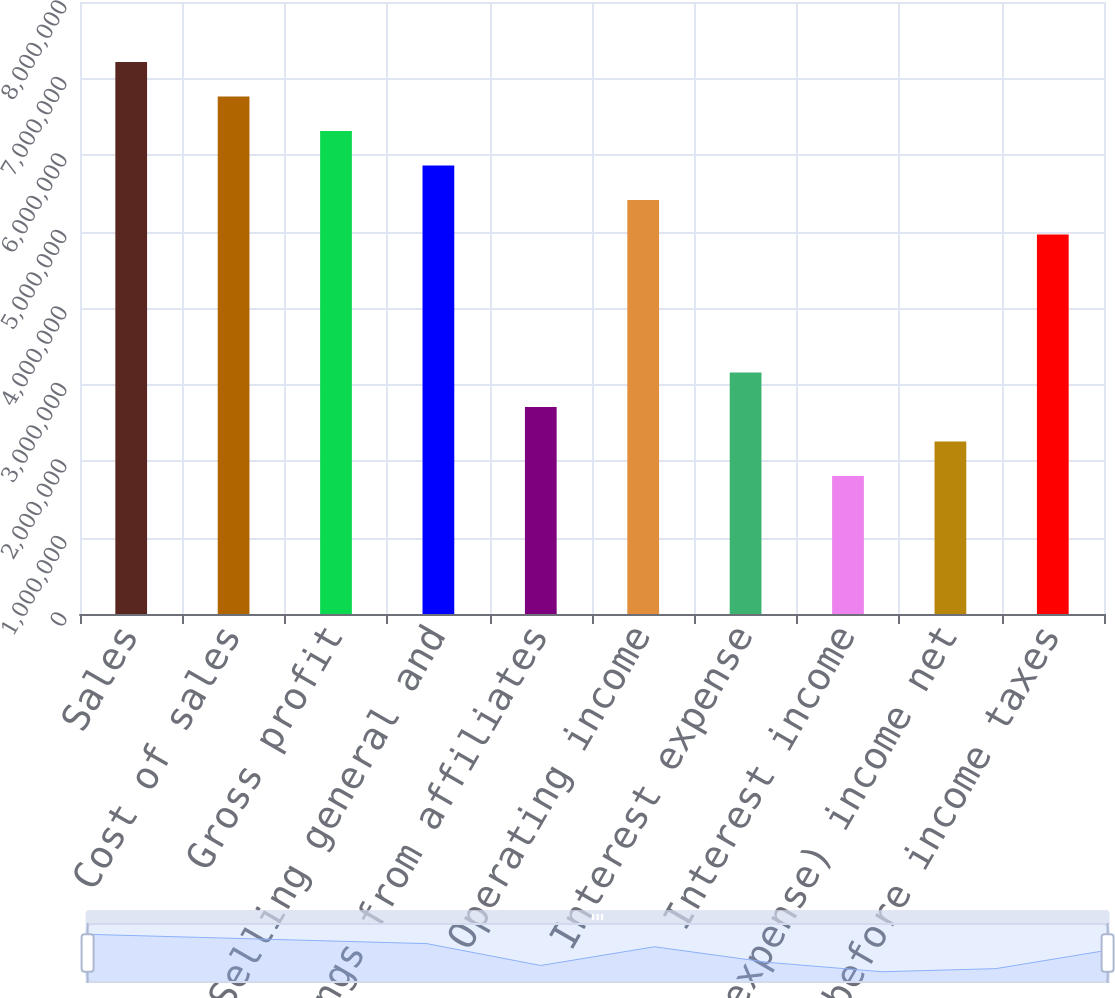Convert chart. <chart><loc_0><loc_0><loc_500><loc_500><bar_chart><fcel>Sales<fcel>Cost of sales<fcel>Gross profit<fcel>Selling general and<fcel>Net earnings from affiliates<fcel>Operating income<fcel>Interest expense<fcel>Interest income<fcel>Other (expense) income net<fcel>Earnings before income taxes<nl><fcel>7.21632e+06<fcel>6.7653e+06<fcel>6.31428e+06<fcel>5.86326e+06<fcel>2.70612e+06<fcel>5.41224e+06<fcel>3.15714e+06<fcel>1.80408e+06<fcel>2.2551e+06<fcel>4.96122e+06<nl></chart> 